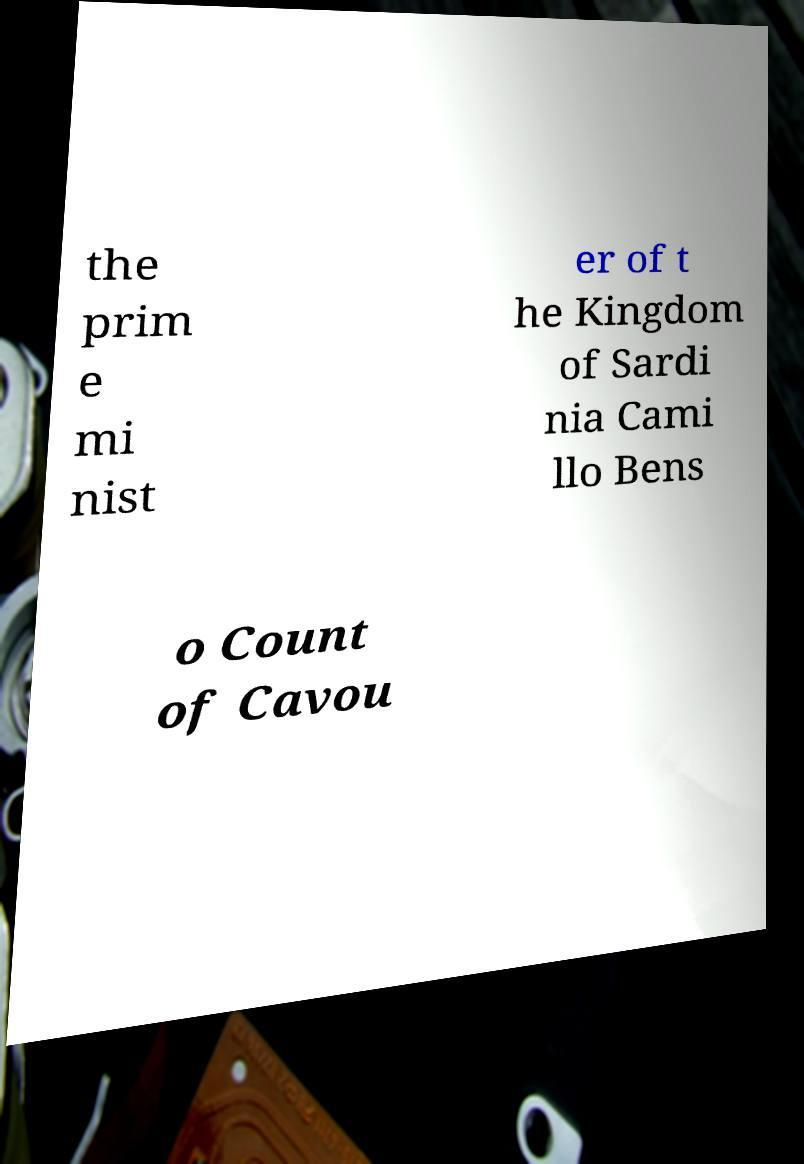I need the written content from this picture converted into text. Can you do that? the prim e mi nist er of t he Kingdom of Sardi nia Cami llo Bens o Count of Cavou 